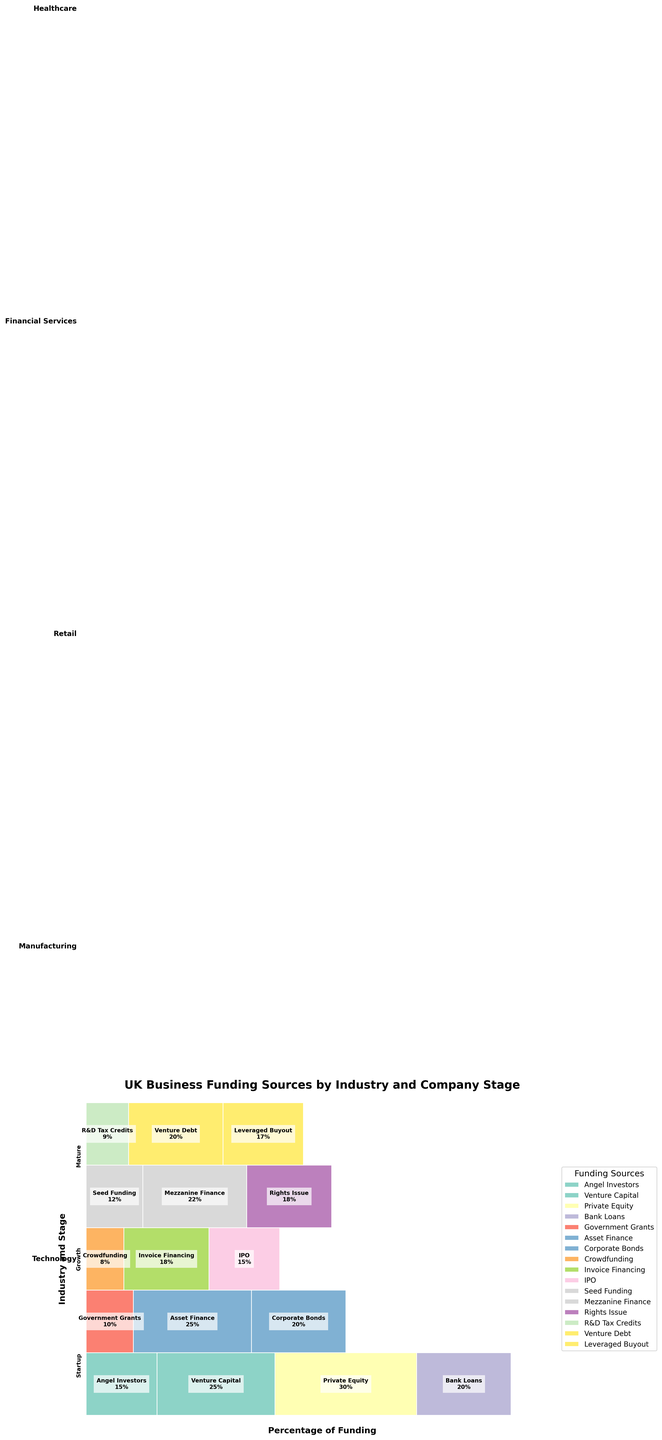Which industry uses angel investors as a funding source at the startup stage? Check the Technology section, noting that it uses 15% angel investors at the startup stage, indicated clearly by the text and color patch.
Answer: Technology What percentage of funding is through venture capital in the healthcare growth stage? Locate the Healthcare section and identify the growth stage, then read the information inside the block for Venture Debt.
Answer: 20% Which funding source is most prevalent in the Financial Services growth stage? Observe the Financial Services section, focusing on the growth stage, and identify the funding source with the largest percentage.
Answer: Mezzanine Finance How does the percentage of funding from government grants in manufacturing startups compare to corporate bonds in mature manufacturing companies? Check the Manufacturing section at both the startup (10% Government Grants) and mature (20% Corporate Bonds) stages, then compare the two percentages.
Answer: Government Grants are less than Corporate Bonds What are the total percentages of funding sources in the technology industry for growth and mature stages combined? Sum the percentages for growth (30% Private Equity) and mature (20% Bank Loans) stages in the Technology section.
Answer: 50% For which industry stage do IPOs account for any funding, and what is its percentage? Look for the Retail industry at the mature stage, where it's labeled as IPO with 15%.
Answer: Retail Mature, 15% Which stage and industry have leveraged buyouts as a funding source, and what is its percentage? Check each industry and stage until you find Healthcare at the mature stage with leveraged buyouts accounting for 17%.
Answer: Healthcare Mature, 17% Between angel investors in technology startups and seed funding in financial services startups, which has a higher percentage? Check both Technology (15%) and Financial Services (12%), then compare the two.
Answer: Angel Investors in Technology How is the funding source of R&D tax credits represented in the mosaic plot, and what stage and industry does it belong to? Locate the funding source R&D Tax Credits in the plot within the Healthcare startup stage.
Answer: R&D Tax Credits in Healthcare Startup What are the primary funding sources for startups in the retail industry, and what is their total percentage? Identify the Retail section's startup stage, noting that Crowdfunding is the funding source at 8%.
Answer: Crowdfunding, 8% 